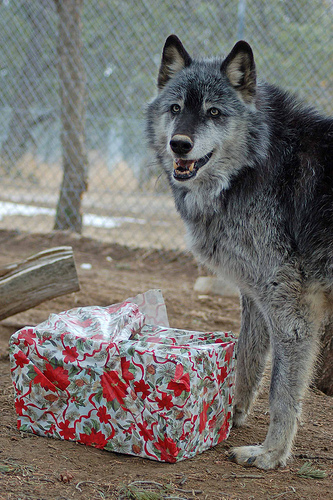<image>
Is there a wolf in front of the box? No. The wolf is not in front of the box. The spatial positioning shows a different relationship between these objects. 